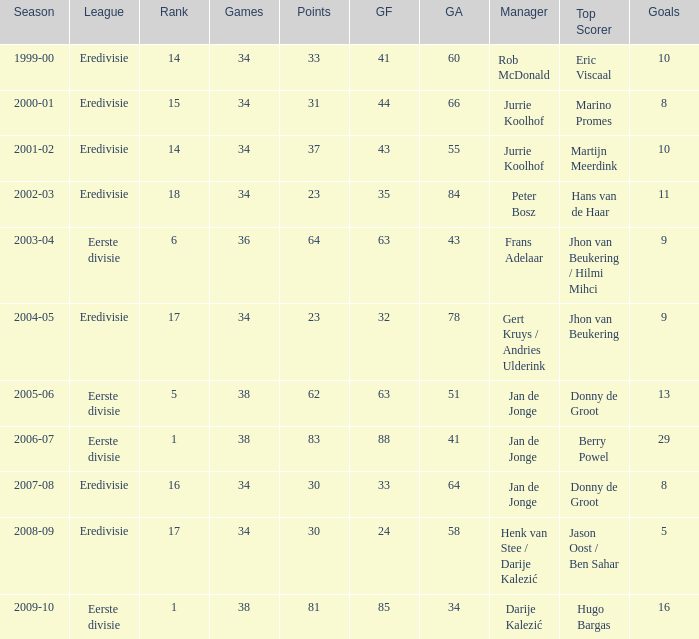Who is the administrator ranked 16th? Jan de Jonge. 